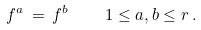Convert formula to latex. <formula><loc_0><loc_0><loc_500><loc_500>f ^ { a } \, = \, f ^ { b } \quad 1 \leq a , b \leq r \, .</formula> 